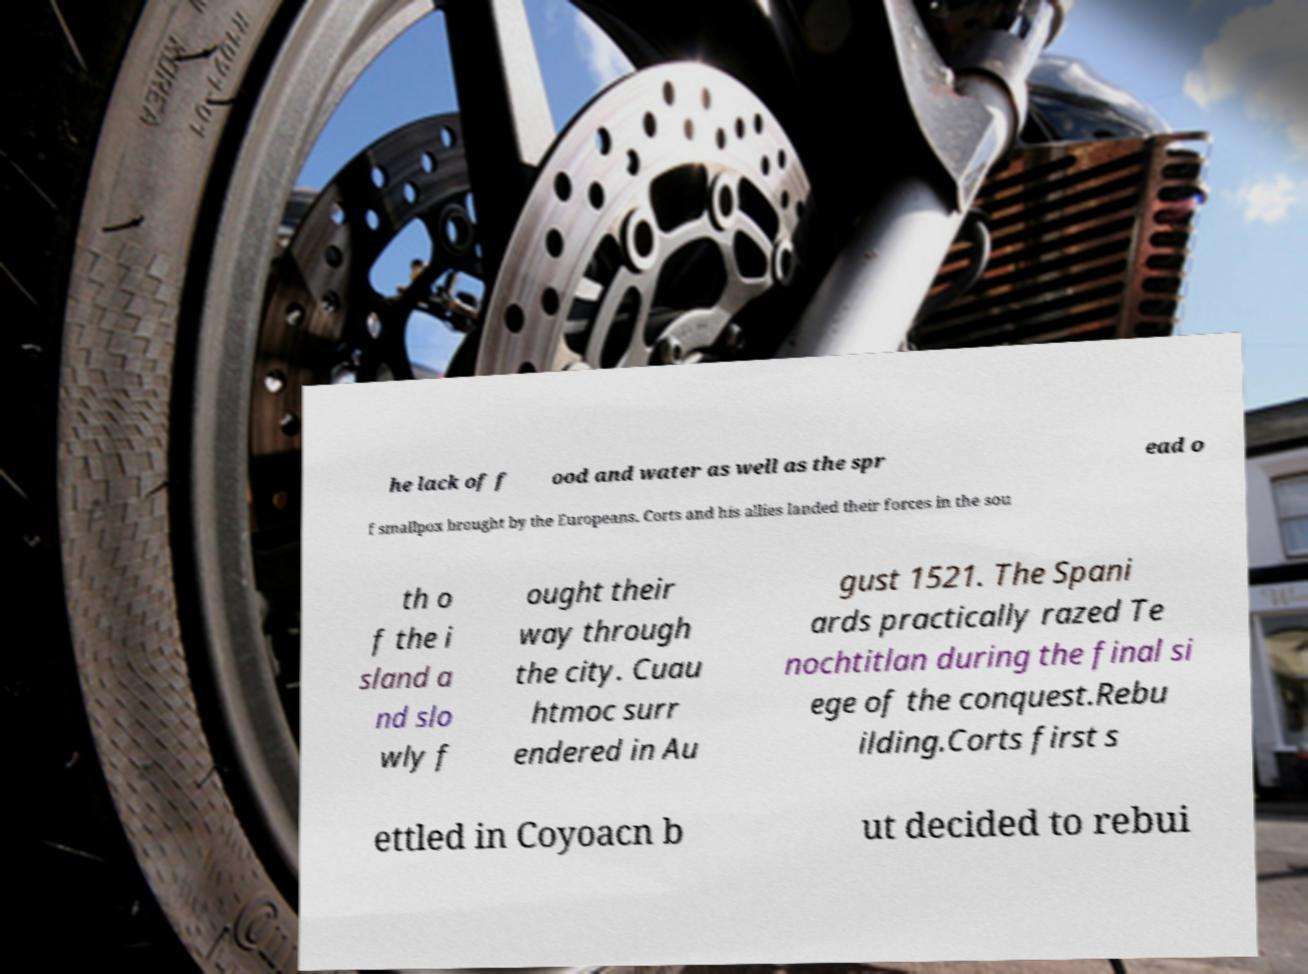What messages or text are displayed in this image? I need them in a readable, typed format. he lack of f ood and water as well as the spr ead o f smallpox brought by the Europeans. Corts and his allies landed their forces in the sou th o f the i sland a nd slo wly f ought their way through the city. Cuau htmoc surr endered in Au gust 1521. The Spani ards practically razed Te nochtitlan during the final si ege of the conquest.Rebu ilding.Corts first s ettled in Coyoacn b ut decided to rebui 